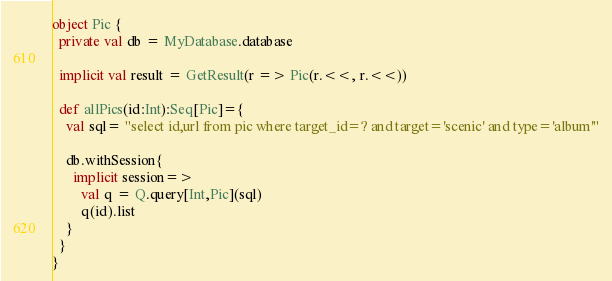Convert code to text. <code><loc_0><loc_0><loc_500><loc_500><_Scala_>
object Pic {
  private val db = MyDatabase.database

  implicit val result = GetResult(r => Pic(r.<<, r.<<))

  def allPics(id:Int):Seq[Pic]={
    val sql= "select id,url from pic where target_id=? and target='scenic' and type='album'"

    db.withSession{
      implicit session=>
        val q = Q.query[Int,Pic](sql)
        q(id).list
    }
  }
}
</code> 